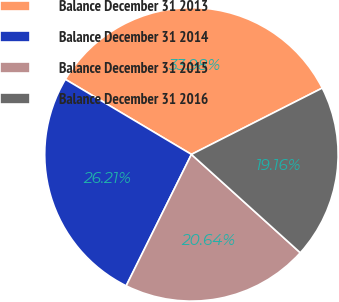Convert chart. <chart><loc_0><loc_0><loc_500><loc_500><pie_chart><fcel>Balance December 31 2013<fcel>Balance December 31 2014<fcel>Balance December 31 2015<fcel>Balance December 31 2016<nl><fcel>33.98%<fcel>26.21%<fcel>20.64%<fcel>19.16%<nl></chart> 